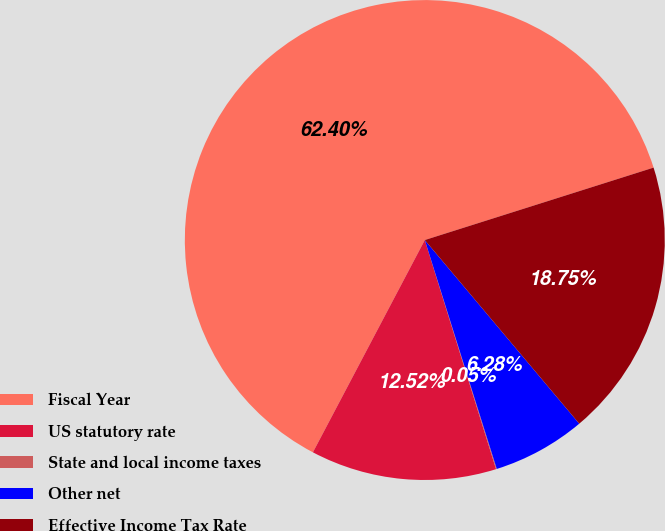Convert chart to OTSL. <chart><loc_0><loc_0><loc_500><loc_500><pie_chart><fcel>Fiscal Year<fcel>US statutory rate<fcel>State and local income taxes<fcel>Other net<fcel>Effective Income Tax Rate<nl><fcel>62.4%<fcel>12.52%<fcel>0.05%<fcel>6.28%<fcel>18.75%<nl></chart> 